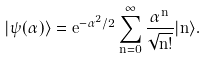<formula> <loc_0><loc_0><loc_500><loc_500>| \psi ( \alpha ) \rangle = e ^ { - \alpha ^ { 2 } / 2 } \sum _ { n = 0 } ^ { \infty } \frac { \alpha ^ { n } } { \sqrt { n ! } } | n \rangle .</formula> 